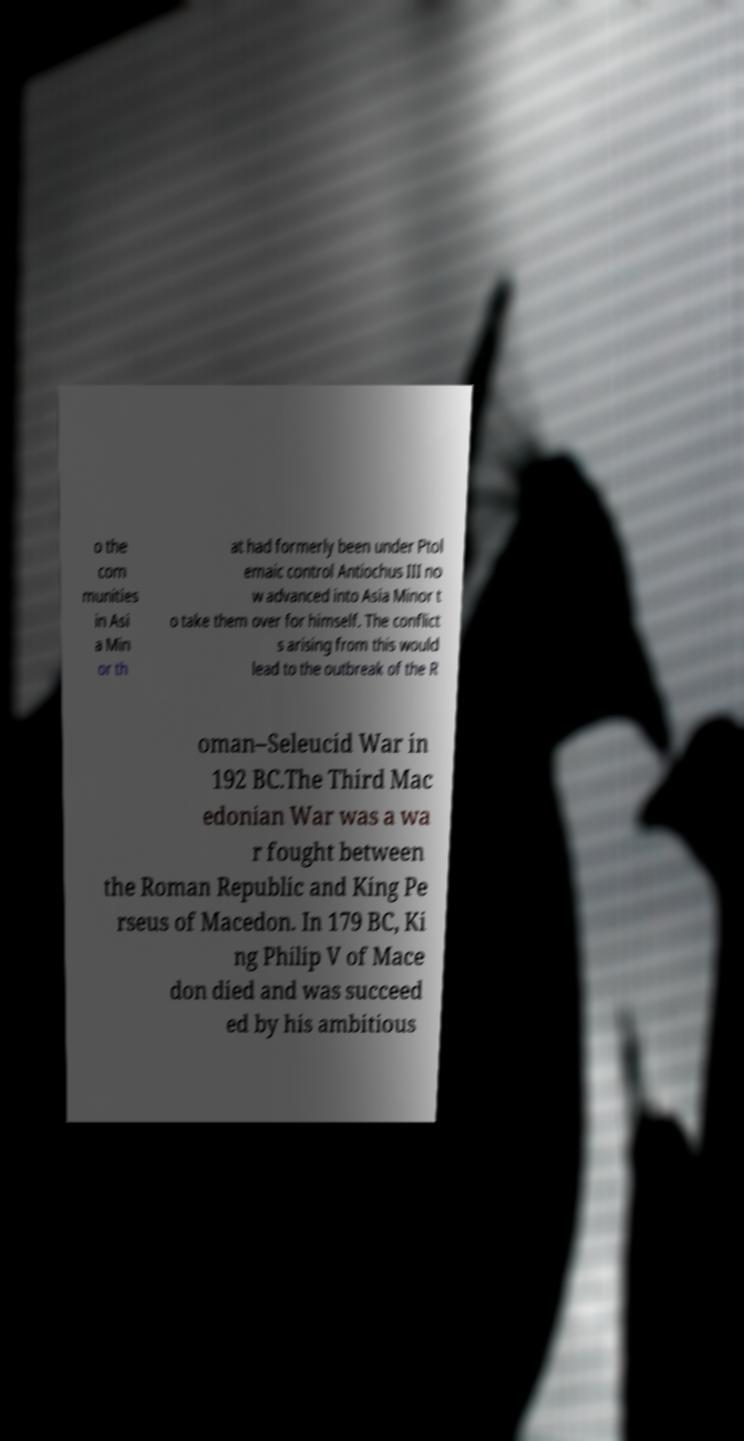I need the written content from this picture converted into text. Can you do that? o the com munities in Asi a Min or th at had formerly been under Ptol emaic control Antiochus III no w advanced into Asia Minor t o take them over for himself. The conflict s arising from this would lead to the outbreak of the R oman–Seleucid War in 192 BC.The Third Mac edonian War was a wa r fought between the Roman Republic and King Pe rseus of Macedon. In 179 BC, Ki ng Philip V of Mace don died and was succeed ed by his ambitious 